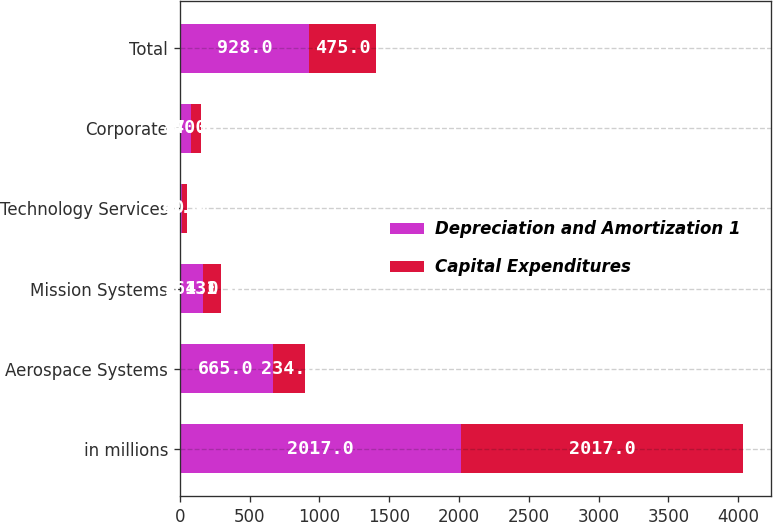Convert chart to OTSL. <chart><loc_0><loc_0><loc_500><loc_500><stacked_bar_chart><ecel><fcel>in millions<fcel>Aerospace Systems<fcel>Mission Systems<fcel>Technology Services<fcel>Corporate<fcel>Total<nl><fcel>Depreciation and Amortization 1<fcel>2017<fcel>665<fcel>164<fcel>15<fcel>84<fcel>928<nl><fcel>Capital Expenditures<fcel>2017<fcel>234<fcel>131<fcel>40<fcel>70<fcel>475<nl></chart> 